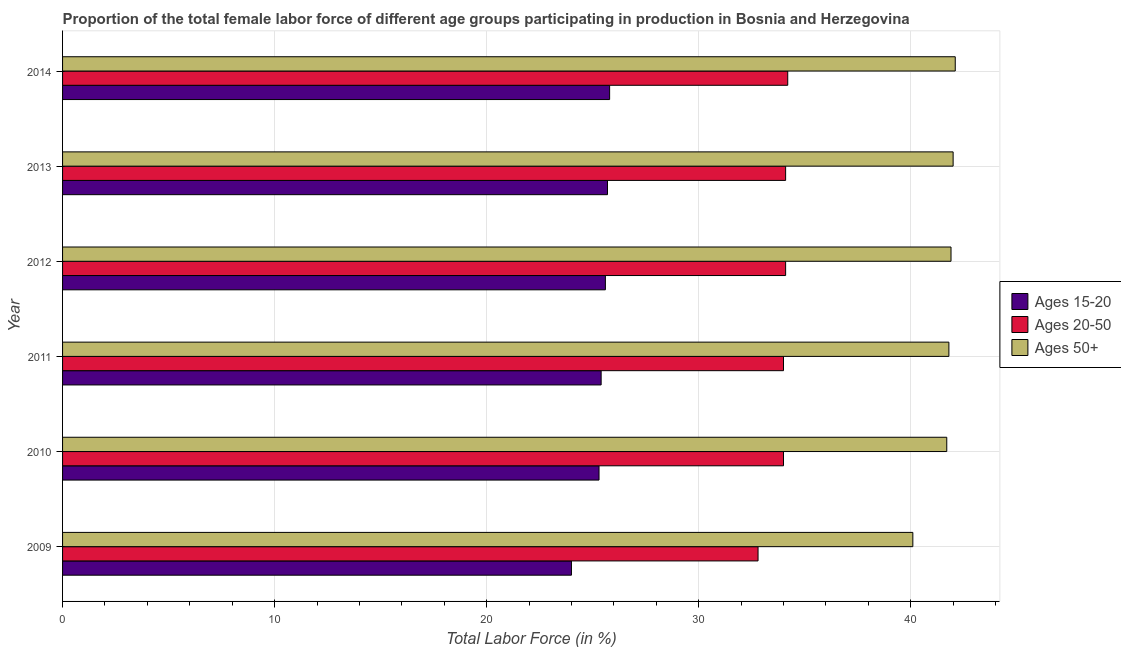How many different coloured bars are there?
Offer a terse response. 3. Are the number of bars per tick equal to the number of legend labels?
Offer a terse response. Yes. How many bars are there on the 5th tick from the bottom?
Make the answer very short. 3. What is the label of the 4th group of bars from the top?
Provide a succinct answer. 2011. What is the percentage of female labor force above age 50 in 2010?
Provide a succinct answer. 41.7. Across all years, what is the maximum percentage of female labor force above age 50?
Offer a terse response. 42.1. Across all years, what is the minimum percentage of female labor force above age 50?
Your response must be concise. 40.1. What is the total percentage of female labor force within the age group 20-50 in the graph?
Provide a succinct answer. 203.2. What is the difference between the percentage of female labor force above age 50 in 2009 and that in 2010?
Provide a succinct answer. -1.6. What is the difference between the percentage of female labor force within the age group 15-20 in 2011 and the percentage of female labor force above age 50 in 2012?
Ensure brevity in your answer.  -16.5. What is the average percentage of female labor force within the age group 15-20 per year?
Make the answer very short. 25.3. In the year 2011, what is the difference between the percentage of female labor force within the age group 20-50 and percentage of female labor force above age 50?
Make the answer very short. -7.8. In how many years, is the percentage of female labor force above age 50 greater than 20 %?
Make the answer very short. 6. What is the difference between the highest and the second highest percentage of female labor force within the age group 15-20?
Provide a short and direct response. 0.1. What is the difference between the highest and the lowest percentage of female labor force within the age group 20-50?
Ensure brevity in your answer.  1.4. Is the sum of the percentage of female labor force above age 50 in 2010 and 2014 greater than the maximum percentage of female labor force within the age group 15-20 across all years?
Provide a succinct answer. Yes. What does the 2nd bar from the top in 2013 represents?
Offer a very short reply. Ages 20-50. What does the 1st bar from the bottom in 2010 represents?
Make the answer very short. Ages 15-20. Are all the bars in the graph horizontal?
Provide a short and direct response. Yes. How many years are there in the graph?
Give a very brief answer. 6. What is the difference between two consecutive major ticks on the X-axis?
Your answer should be compact. 10. Does the graph contain any zero values?
Offer a terse response. No. How many legend labels are there?
Your answer should be compact. 3. What is the title of the graph?
Offer a very short reply. Proportion of the total female labor force of different age groups participating in production in Bosnia and Herzegovina. Does "Ages 50+" appear as one of the legend labels in the graph?
Your answer should be compact. Yes. What is the Total Labor Force (in %) of Ages 20-50 in 2009?
Provide a short and direct response. 32.8. What is the Total Labor Force (in %) of Ages 50+ in 2009?
Your answer should be very brief. 40.1. What is the Total Labor Force (in %) in Ages 15-20 in 2010?
Keep it short and to the point. 25.3. What is the Total Labor Force (in %) in Ages 20-50 in 2010?
Make the answer very short. 34. What is the Total Labor Force (in %) of Ages 50+ in 2010?
Provide a short and direct response. 41.7. What is the Total Labor Force (in %) in Ages 15-20 in 2011?
Offer a terse response. 25.4. What is the Total Labor Force (in %) in Ages 20-50 in 2011?
Your answer should be compact. 34. What is the Total Labor Force (in %) in Ages 50+ in 2011?
Your answer should be very brief. 41.8. What is the Total Labor Force (in %) of Ages 15-20 in 2012?
Offer a terse response. 25.6. What is the Total Labor Force (in %) in Ages 20-50 in 2012?
Your answer should be compact. 34.1. What is the Total Labor Force (in %) in Ages 50+ in 2012?
Your answer should be compact. 41.9. What is the Total Labor Force (in %) of Ages 15-20 in 2013?
Provide a short and direct response. 25.7. What is the Total Labor Force (in %) of Ages 20-50 in 2013?
Offer a terse response. 34.1. What is the Total Labor Force (in %) in Ages 15-20 in 2014?
Your answer should be compact. 25.8. What is the Total Labor Force (in %) in Ages 20-50 in 2014?
Offer a very short reply. 34.2. What is the Total Labor Force (in %) of Ages 50+ in 2014?
Your response must be concise. 42.1. Across all years, what is the maximum Total Labor Force (in %) in Ages 15-20?
Ensure brevity in your answer.  25.8. Across all years, what is the maximum Total Labor Force (in %) in Ages 20-50?
Your answer should be very brief. 34.2. Across all years, what is the maximum Total Labor Force (in %) of Ages 50+?
Your answer should be compact. 42.1. Across all years, what is the minimum Total Labor Force (in %) of Ages 15-20?
Keep it short and to the point. 24. Across all years, what is the minimum Total Labor Force (in %) in Ages 20-50?
Keep it short and to the point. 32.8. Across all years, what is the minimum Total Labor Force (in %) of Ages 50+?
Provide a succinct answer. 40.1. What is the total Total Labor Force (in %) of Ages 15-20 in the graph?
Keep it short and to the point. 151.8. What is the total Total Labor Force (in %) of Ages 20-50 in the graph?
Make the answer very short. 203.2. What is the total Total Labor Force (in %) of Ages 50+ in the graph?
Keep it short and to the point. 249.6. What is the difference between the Total Labor Force (in %) in Ages 15-20 in 2009 and that in 2010?
Make the answer very short. -1.3. What is the difference between the Total Labor Force (in %) in Ages 20-50 in 2009 and that in 2011?
Your response must be concise. -1.2. What is the difference between the Total Labor Force (in %) of Ages 50+ in 2009 and that in 2011?
Keep it short and to the point. -1.7. What is the difference between the Total Labor Force (in %) in Ages 20-50 in 2009 and that in 2012?
Provide a short and direct response. -1.3. What is the difference between the Total Labor Force (in %) of Ages 15-20 in 2009 and that in 2013?
Your answer should be compact. -1.7. What is the difference between the Total Labor Force (in %) of Ages 50+ in 2009 and that in 2013?
Make the answer very short. -1.9. What is the difference between the Total Labor Force (in %) of Ages 20-50 in 2009 and that in 2014?
Offer a very short reply. -1.4. What is the difference between the Total Labor Force (in %) of Ages 50+ in 2009 and that in 2014?
Your answer should be compact. -2. What is the difference between the Total Labor Force (in %) in Ages 50+ in 2010 and that in 2011?
Offer a terse response. -0.1. What is the difference between the Total Labor Force (in %) in Ages 15-20 in 2010 and that in 2012?
Keep it short and to the point. -0.3. What is the difference between the Total Labor Force (in %) in Ages 20-50 in 2010 and that in 2012?
Your response must be concise. -0.1. What is the difference between the Total Labor Force (in %) of Ages 50+ in 2010 and that in 2012?
Your answer should be compact. -0.2. What is the difference between the Total Labor Force (in %) of Ages 20-50 in 2010 and that in 2013?
Offer a terse response. -0.1. What is the difference between the Total Labor Force (in %) of Ages 15-20 in 2010 and that in 2014?
Your answer should be compact. -0.5. What is the difference between the Total Labor Force (in %) in Ages 20-50 in 2010 and that in 2014?
Offer a very short reply. -0.2. What is the difference between the Total Labor Force (in %) of Ages 50+ in 2010 and that in 2014?
Make the answer very short. -0.4. What is the difference between the Total Labor Force (in %) of Ages 15-20 in 2011 and that in 2013?
Your answer should be very brief. -0.3. What is the difference between the Total Labor Force (in %) of Ages 15-20 in 2012 and that in 2013?
Your answer should be very brief. -0.1. What is the difference between the Total Labor Force (in %) of Ages 50+ in 2012 and that in 2013?
Give a very brief answer. -0.1. What is the difference between the Total Labor Force (in %) in Ages 15-20 in 2012 and that in 2014?
Keep it short and to the point. -0.2. What is the difference between the Total Labor Force (in %) of Ages 20-50 in 2012 and that in 2014?
Your answer should be very brief. -0.1. What is the difference between the Total Labor Force (in %) of Ages 15-20 in 2013 and that in 2014?
Your response must be concise. -0.1. What is the difference between the Total Labor Force (in %) of Ages 20-50 in 2013 and that in 2014?
Offer a very short reply. -0.1. What is the difference between the Total Labor Force (in %) of Ages 15-20 in 2009 and the Total Labor Force (in %) of Ages 20-50 in 2010?
Your answer should be compact. -10. What is the difference between the Total Labor Force (in %) in Ages 15-20 in 2009 and the Total Labor Force (in %) in Ages 50+ in 2010?
Your answer should be compact. -17.7. What is the difference between the Total Labor Force (in %) in Ages 20-50 in 2009 and the Total Labor Force (in %) in Ages 50+ in 2010?
Your response must be concise. -8.9. What is the difference between the Total Labor Force (in %) in Ages 15-20 in 2009 and the Total Labor Force (in %) in Ages 50+ in 2011?
Keep it short and to the point. -17.8. What is the difference between the Total Labor Force (in %) of Ages 15-20 in 2009 and the Total Labor Force (in %) of Ages 20-50 in 2012?
Your response must be concise. -10.1. What is the difference between the Total Labor Force (in %) of Ages 15-20 in 2009 and the Total Labor Force (in %) of Ages 50+ in 2012?
Your answer should be compact. -17.9. What is the difference between the Total Labor Force (in %) in Ages 15-20 in 2009 and the Total Labor Force (in %) in Ages 20-50 in 2013?
Make the answer very short. -10.1. What is the difference between the Total Labor Force (in %) in Ages 15-20 in 2009 and the Total Labor Force (in %) in Ages 50+ in 2013?
Offer a terse response. -18. What is the difference between the Total Labor Force (in %) of Ages 15-20 in 2009 and the Total Labor Force (in %) of Ages 50+ in 2014?
Keep it short and to the point. -18.1. What is the difference between the Total Labor Force (in %) in Ages 20-50 in 2009 and the Total Labor Force (in %) in Ages 50+ in 2014?
Your response must be concise. -9.3. What is the difference between the Total Labor Force (in %) of Ages 15-20 in 2010 and the Total Labor Force (in %) of Ages 50+ in 2011?
Your answer should be very brief. -16.5. What is the difference between the Total Labor Force (in %) in Ages 20-50 in 2010 and the Total Labor Force (in %) in Ages 50+ in 2011?
Your answer should be very brief. -7.8. What is the difference between the Total Labor Force (in %) of Ages 15-20 in 2010 and the Total Labor Force (in %) of Ages 50+ in 2012?
Your answer should be very brief. -16.6. What is the difference between the Total Labor Force (in %) in Ages 20-50 in 2010 and the Total Labor Force (in %) in Ages 50+ in 2012?
Offer a terse response. -7.9. What is the difference between the Total Labor Force (in %) in Ages 15-20 in 2010 and the Total Labor Force (in %) in Ages 20-50 in 2013?
Offer a very short reply. -8.8. What is the difference between the Total Labor Force (in %) of Ages 15-20 in 2010 and the Total Labor Force (in %) of Ages 50+ in 2013?
Provide a succinct answer. -16.7. What is the difference between the Total Labor Force (in %) in Ages 20-50 in 2010 and the Total Labor Force (in %) in Ages 50+ in 2013?
Offer a terse response. -8. What is the difference between the Total Labor Force (in %) in Ages 15-20 in 2010 and the Total Labor Force (in %) in Ages 20-50 in 2014?
Keep it short and to the point. -8.9. What is the difference between the Total Labor Force (in %) in Ages 15-20 in 2010 and the Total Labor Force (in %) in Ages 50+ in 2014?
Make the answer very short. -16.8. What is the difference between the Total Labor Force (in %) in Ages 20-50 in 2010 and the Total Labor Force (in %) in Ages 50+ in 2014?
Your answer should be very brief. -8.1. What is the difference between the Total Labor Force (in %) in Ages 15-20 in 2011 and the Total Labor Force (in %) in Ages 50+ in 2012?
Offer a terse response. -16.5. What is the difference between the Total Labor Force (in %) in Ages 15-20 in 2011 and the Total Labor Force (in %) in Ages 20-50 in 2013?
Give a very brief answer. -8.7. What is the difference between the Total Labor Force (in %) in Ages 15-20 in 2011 and the Total Labor Force (in %) in Ages 50+ in 2013?
Provide a short and direct response. -16.6. What is the difference between the Total Labor Force (in %) of Ages 15-20 in 2011 and the Total Labor Force (in %) of Ages 50+ in 2014?
Provide a short and direct response. -16.7. What is the difference between the Total Labor Force (in %) of Ages 15-20 in 2012 and the Total Labor Force (in %) of Ages 50+ in 2013?
Your answer should be very brief. -16.4. What is the difference between the Total Labor Force (in %) in Ages 15-20 in 2012 and the Total Labor Force (in %) in Ages 50+ in 2014?
Offer a very short reply. -16.5. What is the difference between the Total Labor Force (in %) in Ages 20-50 in 2012 and the Total Labor Force (in %) in Ages 50+ in 2014?
Your answer should be compact. -8. What is the difference between the Total Labor Force (in %) of Ages 15-20 in 2013 and the Total Labor Force (in %) of Ages 20-50 in 2014?
Keep it short and to the point. -8.5. What is the difference between the Total Labor Force (in %) in Ages 15-20 in 2013 and the Total Labor Force (in %) in Ages 50+ in 2014?
Your response must be concise. -16.4. What is the difference between the Total Labor Force (in %) of Ages 20-50 in 2013 and the Total Labor Force (in %) of Ages 50+ in 2014?
Offer a terse response. -8. What is the average Total Labor Force (in %) in Ages 15-20 per year?
Ensure brevity in your answer.  25.3. What is the average Total Labor Force (in %) of Ages 20-50 per year?
Your answer should be very brief. 33.87. What is the average Total Labor Force (in %) of Ages 50+ per year?
Ensure brevity in your answer.  41.6. In the year 2009, what is the difference between the Total Labor Force (in %) in Ages 15-20 and Total Labor Force (in %) in Ages 50+?
Your response must be concise. -16.1. In the year 2010, what is the difference between the Total Labor Force (in %) of Ages 15-20 and Total Labor Force (in %) of Ages 20-50?
Your answer should be very brief. -8.7. In the year 2010, what is the difference between the Total Labor Force (in %) of Ages 15-20 and Total Labor Force (in %) of Ages 50+?
Provide a short and direct response. -16.4. In the year 2010, what is the difference between the Total Labor Force (in %) of Ages 20-50 and Total Labor Force (in %) of Ages 50+?
Offer a terse response. -7.7. In the year 2011, what is the difference between the Total Labor Force (in %) of Ages 15-20 and Total Labor Force (in %) of Ages 50+?
Your response must be concise. -16.4. In the year 2011, what is the difference between the Total Labor Force (in %) of Ages 20-50 and Total Labor Force (in %) of Ages 50+?
Offer a very short reply. -7.8. In the year 2012, what is the difference between the Total Labor Force (in %) in Ages 15-20 and Total Labor Force (in %) in Ages 20-50?
Provide a succinct answer. -8.5. In the year 2012, what is the difference between the Total Labor Force (in %) of Ages 15-20 and Total Labor Force (in %) of Ages 50+?
Your answer should be compact. -16.3. In the year 2012, what is the difference between the Total Labor Force (in %) in Ages 20-50 and Total Labor Force (in %) in Ages 50+?
Your answer should be very brief. -7.8. In the year 2013, what is the difference between the Total Labor Force (in %) in Ages 15-20 and Total Labor Force (in %) in Ages 50+?
Provide a short and direct response. -16.3. In the year 2014, what is the difference between the Total Labor Force (in %) in Ages 15-20 and Total Labor Force (in %) in Ages 50+?
Ensure brevity in your answer.  -16.3. In the year 2014, what is the difference between the Total Labor Force (in %) of Ages 20-50 and Total Labor Force (in %) of Ages 50+?
Offer a terse response. -7.9. What is the ratio of the Total Labor Force (in %) in Ages 15-20 in 2009 to that in 2010?
Give a very brief answer. 0.95. What is the ratio of the Total Labor Force (in %) in Ages 20-50 in 2009 to that in 2010?
Offer a terse response. 0.96. What is the ratio of the Total Labor Force (in %) of Ages 50+ in 2009 to that in 2010?
Your answer should be compact. 0.96. What is the ratio of the Total Labor Force (in %) of Ages 15-20 in 2009 to that in 2011?
Provide a succinct answer. 0.94. What is the ratio of the Total Labor Force (in %) in Ages 20-50 in 2009 to that in 2011?
Your answer should be very brief. 0.96. What is the ratio of the Total Labor Force (in %) of Ages 50+ in 2009 to that in 2011?
Offer a very short reply. 0.96. What is the ratio of the Total Labor Force (in %) of Ages 15-20 in 2009 to that in 2012?
Keep it short and to the point. 0.94. What is the ratio of the Total Labor Force (in %) in Ages 20-50 in 2009 to that in 2012?
Your response must be concise. 0.96. What is the ratio of the Total Labor Force (in %) in Ages 15-20 in 2009 to that in 2013?
Give a very brief answer. 0.93. What is the ratio of the Total Labor Force (in %) in Ages 20-50 in 2009 to that in 2013?
Keep it short and to the point. 0.96. What is the ratio of the Total Labor Force (in %) of Ages 50+ in 2009 to that in 2013?
Provide a short and direct response. 0.95. What is the ratio of the Total Labor Force (in %) of Ages 15-20 in 2009 to that in 2014?
Make the answer very short. 0.93. What is the ratio of the Total Labor Force (in %) of Ages 20-50 in 2009 to that in 2014?
Your answer should be compact. 0.96. What is the ratio of the Total Labor Force (in %) of Ages 50+ in 2009 to that in 2014?
Provide a short and direct response. 0.95. What is the ratio of the Total Labor Force (in %) in Ages 20-50 in 2010 to that in 2011?
Your answer should be compact. 1. What is the ratio of the Total Labor Force (in %) in Ages 15-20 in 2010 to that in 2012?
Keep it short and to the point. 0.99. What is the ratio of the Total Labor Force (in %) in Ages 20-50 in 2010 to that in 2012?
Your answer should be very brief. 1. What is the ratio of the Total Labor Force (in %) in Ages 15-20 in 2010 to that in 2013?
Your answer should be compact. 0.98. What is the ratio of the Total Labor Force (in %) of Ages 50+ in 2010 to that in 2013?
Your answer should be very brief. 0.99. What is the ratio of the Total Labor Force (in %) in Ages 15-20 in 2010 to that in 2014?
Keep it short and to the point. 0.98. What is the ratio of the Total Labor Force (in %) in Ages 50+ in 2010 to that in 2014?
Offer a very short reply. 0.99. What is the ratio of the Total Labor Force (in %) in Ages 20-50 in 2011 to that in 2012?
Offer a terse response. 1. What is the ratio of the Total Labor Force (in %) in Ages 15-20 in 2011 to that in 2013?
Offer a very short reply. 0.99. What is the ratio of the Total Labor Force (in %) in Ages 20-50 in 2011 to that in 2013?
Provide a succinct answer. 1. What is the ratio of the Total Labor Force (in %) of Ages 15-20 in 2011 to that in 2014?
Your answer should be compact. 0.98. What is the ratio of the Total Labor Force (in %) in Ages 20-50 in 2011 to that in 2014?
Your response must be concise. 0.99. What is the ratio of the Total Labor Force (in %) in Ages 50+ in 2011 to that in 2014?
Give a very brief answer. 0.99. What is the ratio of the Total Labor Force (in %) of Ages 15-20 in 2012 to that in 2013?
Your answer should be very brief. 1. What is the ratio of the Total Labor Force (in %) in Ages 20-50 in 2012 to that in 2013?
Make the answer very short. 1. What is the ratio of the Total Labor Force (in %) in Ages 50+ in 2012 to that in 2013?
Provide a succinct answer. 1. What is the ratio of the Total Labor Force (in %) in Ages 15-20 in 2012 to that in 2014?
Keep it short and to the point. 0.99. What is the ratio of the Total Labor Force (in %) of Ages 50+ in 2012 to that in 2014?
Offer a very short reply. 1. What is the ratio of the Total Labor Force (in %) of Ages 15-20 in 2013 to that in 2014?
Offer a terse response. 1. What is the ratio of the Total Labor Force (in %) of Ages 20-50 in 2013 to that in 2014?
Offer a very short reply. 1. What is the ratio of the Total Labor Force (in %) of Ages 50+ in 2013 to that in 2014?
Your response must be concise. 1. What is the difference between the highest and the second highest Total Labor Force (in %) of Ages 15-20?
Provide a succinct answer. 0.1. What is the difference between the highest and the lowest Total Labor Force (in %) in Ages 20-50?
Provide a short and direct response. 1.4. What is the difference between the highest and the lowest Total Labor Force (in %) of Ages 50+?
Your answer should be compact. 2. 